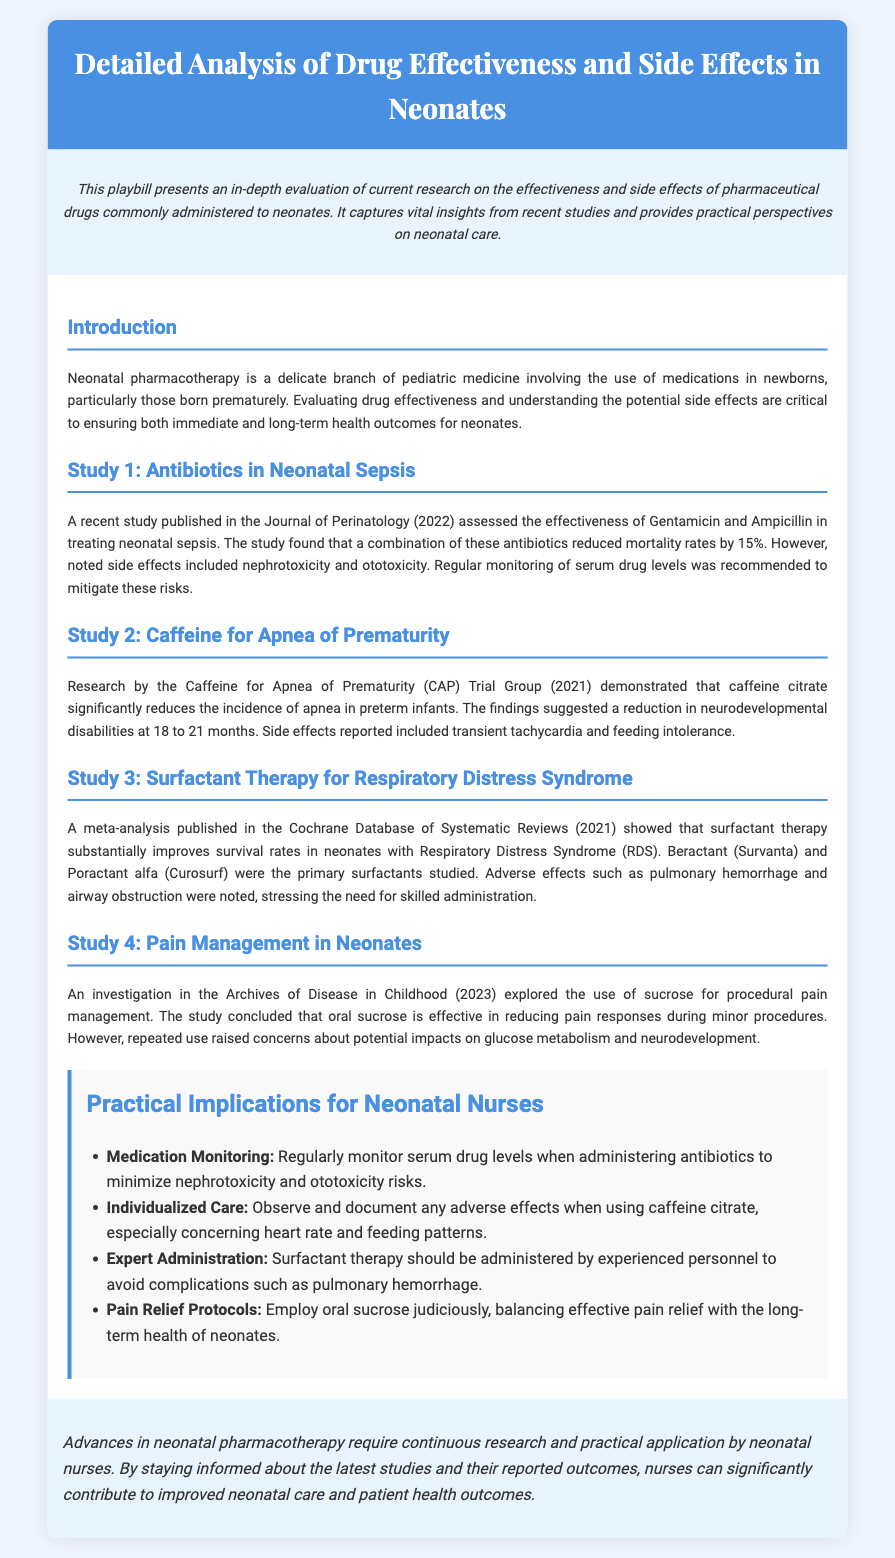What is the primary focus of the document? The document focuses on evaluating the effectiveness and side effects of drugs administered to neonates.
Answer: Evaluating the effectiveness and side effects of drugs administered to neonates Which medication combination reduced neonatal sepsis mortality rates by 15%? The combination of Gentamicin and Ampicillin was mentioned in relation to reducing mortality rates in neonatal sepsis.
Answer: Gentamicin and Ampicillin What significant effect does caffeine citrate have on preterm infants? The study indicates that caffeine citrate significantly reduces the incidence of apnea in preterm infants.
Answer: Reduces incidence of apnea What are the two primary surfactants studied in surfactant therapy? The document mentions Beractant (Survanta) and Poractant alfa (Curosurf) as the primary surfactants.
Answer: Beractant (Survanta) and Poractant alfa (Curosurf) Which study examined sucrose as a pain management technique? The investigation regarding sucrose for procedural pain management was published in the Archives of Disease in Childhood.
Answer: Archives of Disease in Childhood What year was the study on caffeine for apnea of prematurity published? The research by the Caffeine for Apnea of Prematurity Trial Group was published in 2021.
Answer: 2021 What is one side effect of using caffeine citrate? The document states that transient tachycardia is a reported side effect of caffeine citrate.
Answer: Transient tachycardia What is highlighted as an important aspect of surfactant therapy administration? The document emphasizes that surfactant therapy should be administered by experienced personnel to avoid complications.
Answer: Administered by experienced personnel 